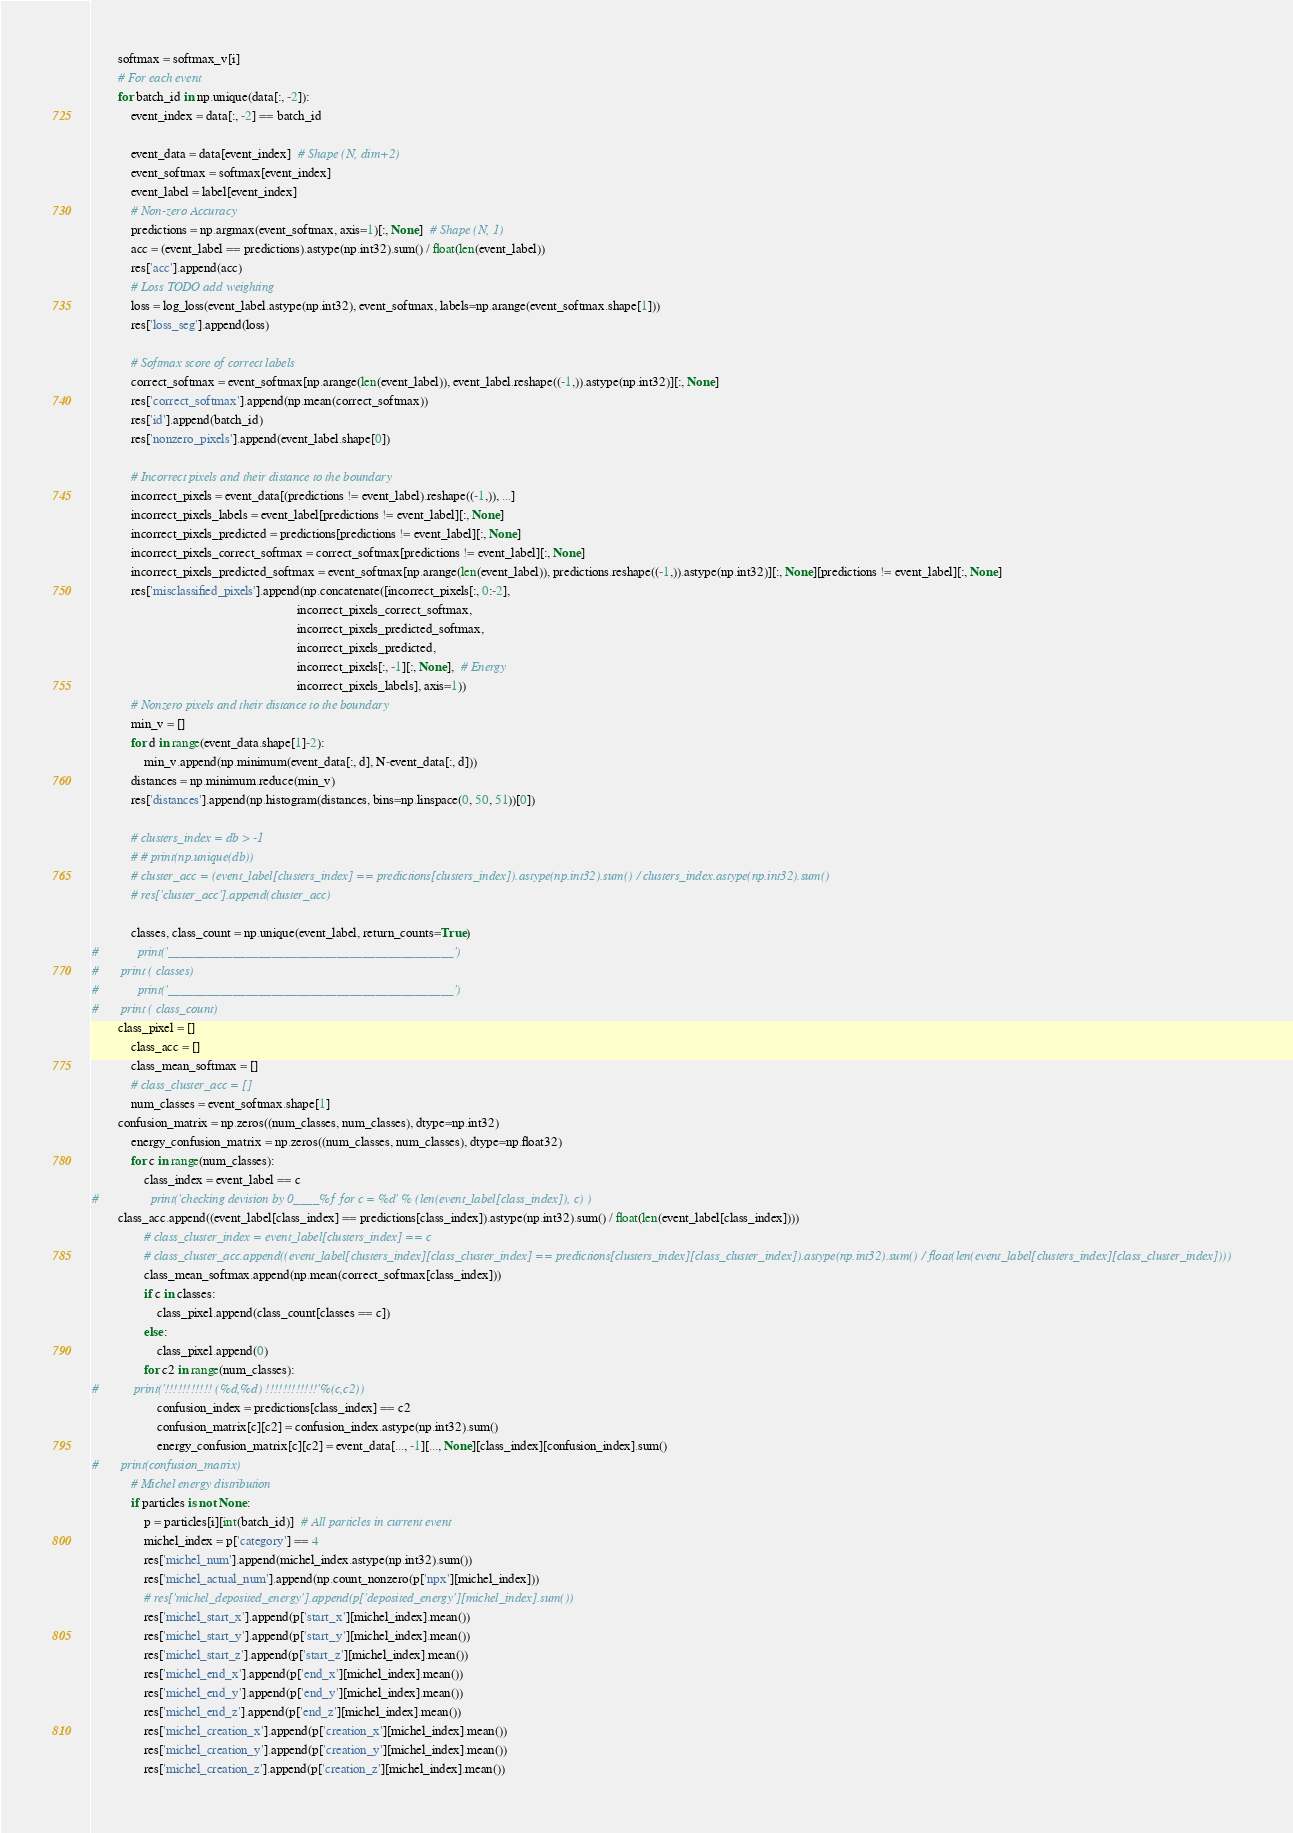Convert code to text. <code><loc_0><loc_0><loc_500><loc_500><_Python_>        softmax = softmax_v[i]
        # For each event
        for batch_id in np.unique(data[:, -2]):
            event_index = data[:, -2] == batch_id

            event_data = data[event_index]  # Shape (N, dim+2)
            event_softmax = softmax[event_index]
            event_label = label[event_index]
            # Non-zero Accuracy
            predictions = np.argmax(event_softmax, axis=1)[:, None]  # Shape (N, 1)
            acc = (event_label == predictions).astype(np.int32).sum() / float(len(event_label))
            res['acc'].append(acc)
            # Loss TODO add weighting
            loss = log_loss(event_label.astype(np.int32), event_softmax, labels=np.arange(event_softmax.shape[1]))
            res['loss_seg'].append(loss)

            # Softmax score of correct labels
            correct_softmax = event_softmax[np.arange(len(event_label)), event_label.reshape((-1,)).astype(np.int32)][:, None]
            res['correct_softmax'].append(np.mean(correct_softmax))
            res['id'].append(batch_id)
            res['nonzero_pixels'].append(event_label.shape[0])

            # Incorrect pixels and their distance to the boundary
            incorrect_pixels = event_data[(predictions != event_label).reshape((-1,)), ...]
            incorrect_pixels_labels = event_label[predictions != event_label][:, None]
            incorrect_pixels_predicted = predictions[predictions != event_label][:, None]
            incorrect_pixels_correct_softmax = correct_softmax[predictions != event_label][:, None]
            incorrect_pixels_predicted_softmax = event_softmax[np.arange(len(event_label)), predictions.reshape((-1,)).astype(np.int32)][:, None][predictions != event_label][:, None]
            res['misclassified_pixels'].append(np.concatenate([incorrect_pixels[:, 0:-2],
                                                               incorrect_pixels_correct_softmax,
                                                               incorrect_pixels_predicted_softmax,
                                                               incorrect_pixels_predicted,
                                                               incorrect_pixels[:, -1][:, None],  # Energy
                                                               incorrect_pixels_labels], axis=1))
            # Nonzero pixels and their distance to the boundary
            min_v = []
            for d in range(event_data.shape[1]-2):
                min_v.append(np.minimum(event_data[:, d], N-event_data[:, d]))
            distances = np.minimum.reduce(min_v)
            res['distances'].append(np.histogram(distances, bins=np.linspace(0, 50, 51))[0])

            # clusters_index = db > -1
            # # print(np.unique(db))
            # cluster_acc = (event_label[clusters_index] == predictions[clusters_index]).astype(np.int32).sum() / clusters_index.astype(np.int32).sum()
            # res['cluster_acc'].append(cluster_acc)

            classes, class_count = np.unique(event_label, return_counts=True)
#            print('____________________________________________')
#	    print ( classes)
#            print('____________________________________________')
# 	    print ( class_count)
	    class_pixel = []
            class_acc = []
            class_mean_softmax = []
            # class_cluster_acc = []
            num_classes = event_softmax.shape[1]
	    confusion_matrix = np.zeros((num_classes, num_classes), dtype=np.int32)
            energy_confusion_matrix = np.zeros((num_classes, num_classes), dtype=np.float32)
            for c in range(num_classes):
                class_index = event_label == c
#                print('checking devision by 0____%f for c = %d' % (len(event_label[class_index]), c) )
		class_acc.append((event_label[class_index] == predictions[class_index]).astype(np.int32).sum() / float(len(event_label[class_index])))
                # class_cluster_index = event_label[clusters_index] == c
                # class_cluster_acc.append((event_label[clusters_index][class_cluster_index] == predictions[clusters_index][class_cluster_index]).astype(np.int32).sum() / float(len(event_label[clusters_index][class_cluster_index])))
                class_mean_softmax.append(np.mean(correct_softmax[class_index]))
                if c in classes:
                    class_pixel.append(class_count[classes == c])
                else:
                    class_pixel.append(0)
                for c2 in range(num_classes):
#		    print('!!!!!!!!!!! (%d,%d) !!!!!!!!!!!!'%(c,c2))
                    confusion_index = predictions[class_index] == c2
                    confusion_matrix[c][c2] = confusion_index.astype(np.int32).sum()
                    energy_confusion_matrix[c][c2] = event_data[..., -1][..., None][class_index][confusion_index].sum()
#	    print(confusion_matrix)
            # Michel energy distribution
            if particles is not None:
                p = particles[i][int(batch_id)]  # All particles in current event
                michel_index = p['category'] == 4
                res['michel_num'].append(michel_index.astype(np.int32).sum())
                res['michel_actual_num'].append(np.count_nonzero(p['npx'][michel_index]))
                # res['michel_deposited_energy'].append(p['deposited_energy'][michel_index].sum())
                res['michel_start_x'].append(p['start_x'][michel_index].mean())
                res['michel_start_y'].append(p['start_y'][michel_index].mean())
                res['michel_start_z'].append(p['start_z'][michel_index].mean())
                res['michel_end_x'].append(p['end_x'][michel_index].mean())
                res['michel_end_y'].append(p['end_y'][michel_index].mean())
                res['michel_end_z'].append(p['end_z'][michel_index].mean())
                res['michel_creation_x'].append(p['creation_x'][michel_index].mean())
                res['michel_creation_y'].append(p['creation_y'][michel_index].mean())
                res['michel_creation_z'].append(p['creation_z'][michel_index].mean())</code> 